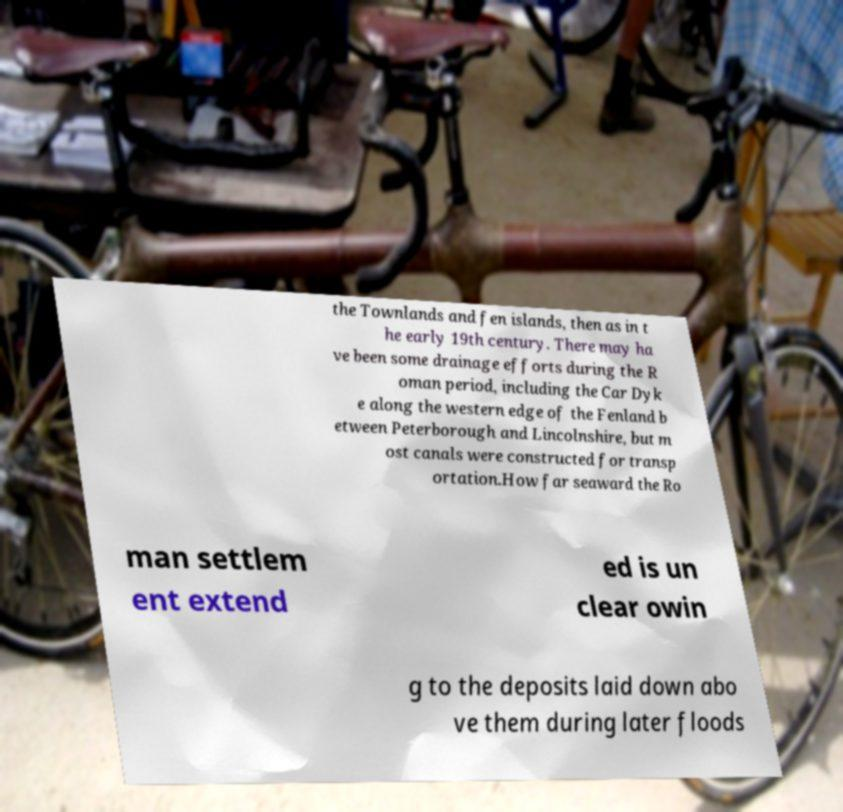Please read and relay the text visible in this image. What does it say? the Townlands and fen islands, then as in t he early 19th century. There may ha ve been some drainage efforts during the R oman period, including the Car Dyk e along the western edge of the Fenland b etween Peterborough and Lincolnshire, but m ost canals were constructed for transp ortation.How far seaward the Ro man settlem ent extend ed is un clear owin g to the deposits laid down abo ve them during later floods 